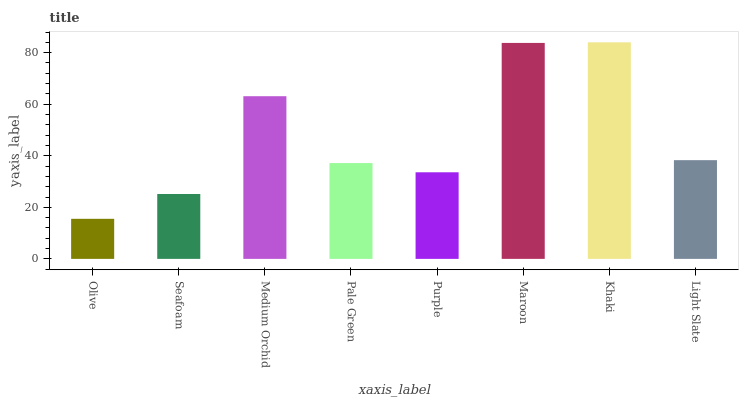Is Olive the minimum?
Answer yes or no. Yes. Is Khaki the maximum?
Answer yes or no. Yes. Is Seafoam the minimum?
Answer yes or no. No. Is Seafoam the maximum?
Answer yes or no. No. Is Seafoam greater than Olive?
Answer yes or no. Yes. Is Olive less than Seafoam?
Answer yes or no. Yes. Is Olive greater than Seafoam?
Answer yes or no. No. Is Seafoam less than Olive?
Answer yes or no. No. Is Light Slate the high median?
Answer yes or no. Yes. Is Pale Green the low median?
Answer yes or no. Yes. Is Olive the high median?
Answer yes or no. No. Is Purple the low median?
Answer yes or no. No. 